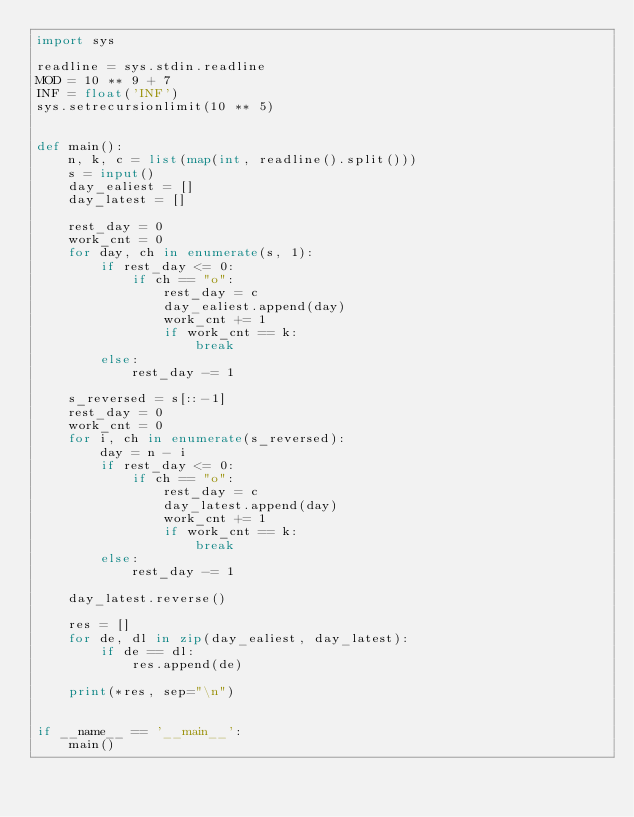Convert code to text. <code><loc_0><loc_0><loc_500><loc_500><_Python_>import sys

readline = sys.stdin.readline
MOD = 10 ** 9 + 7
INF = float('INF')
sys.setrecursionlimit(10 ** 5)


def main():
    n, k, c = list(map(int, readline().split()))
    s = input()
    day_ealiest = []
    day_latest = []

    rest_day = 0
    work_cnt = 0
    for day, ch in enumerate(s, 1):
        if rest_day <= 0:
            if ch == "o":
                rest_day = c
                day_ealiest.append(day)
                work_cnt += 1
                if work_cnt == k:
                    break
        else:
            rest_day -= 1

    s_reversed = s[::-1]
    rest_day = 0
    work_cnt = 0
    for i, ch in enumerate(s_reversed):
        day = n - i
        if rest_day <= 0:
            if ch == "o":
                rest_day = c
                day_latest.append(day)
                work_cnt += 1
                if work_cnt == k:
                    break
        else:
            rest_day -= 1

    day_latest.reverse()

    res = []
    for de, dl in zip(day_ealiest, day_latest):
        if de == dl:
            res.append(de)

    print(*res, sep="\n")


if __name__ == '__main__':
    main()
</code> 